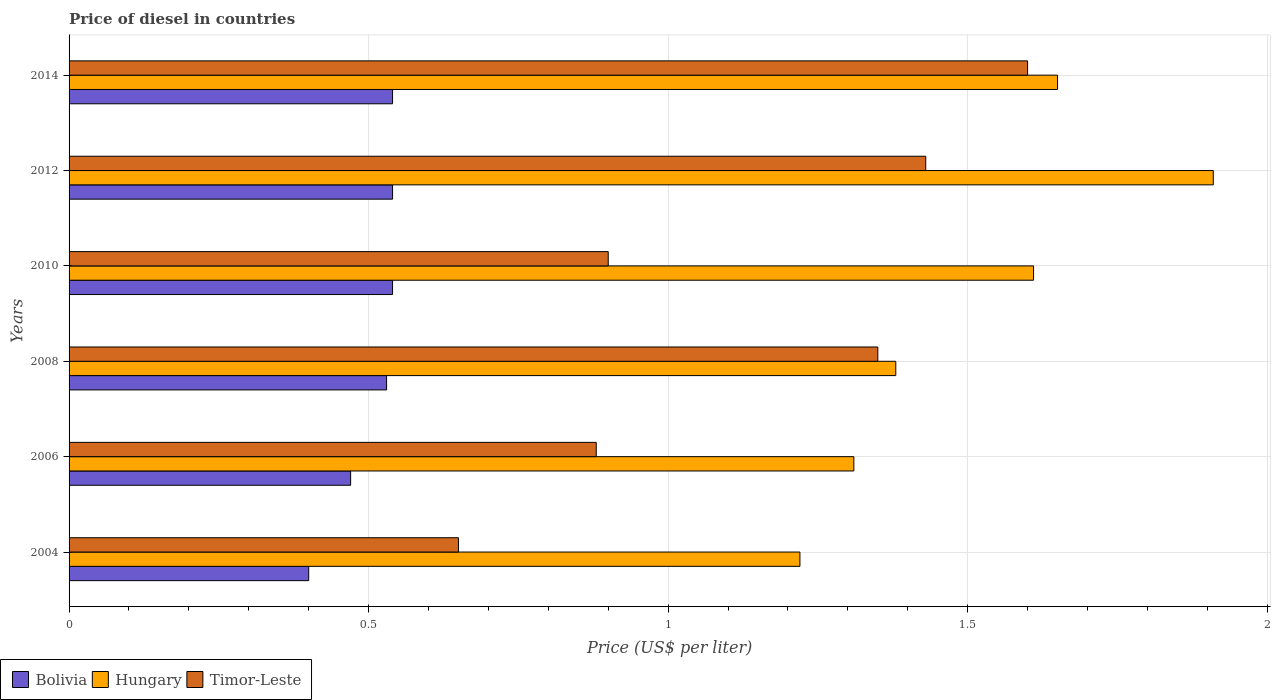How many groups of bars are there?
Offer a very short reply. 6. Are the number of bars per tick equal to the number of legend labels?
Offer a terse response. Yes. How many bars are there on the 4th tick from the bottom?
Offer a very short reply. 3. What is the price of diesel in Timor-Leste in 2006?
Your answer should be compact. 0.88. Across all years, what is the maximum price of diesel in Bolivia?
Your answer should be compact. 0.54. Across all years, what is the minimum price of diesel in Hungary?
Your answer should be compact. 1.22. In which year was the price of diesel in Hungary maximum?
Your response must be concise. 2012. In which year was the price of diesel in Hungary minimum?
Provide a short and direct response. 2004. What is the total price of diesel in Timor-Leste in the graph?
Provide a short and direct response. 6.81. What is the difference between the price of diesel in Bolivia in 2004 and that in 2010?
Provide a succinct answer. -0.14. What is the difference between the price of diesel in Hungary in 2010 and the price of diesel in Timor-Leste in 2014?
Your answer should be compact. 0.01. What is the average price of diesel in Hungary per year?
Make the answer very short. 1.51. In the year 2006, what is the difference between the price of diesel in Hungary and price of diesel in Timor-Leste?
Provide a short and direct response. 0.43. In how many years, is the price of diesel in Hungary greater than 0.8 US$?
Provide a succinct answer. 6. What is the ratio of the price of diesel in Hungary in 2012 to that in 2014?
Your response must be concise. 1.16. Is the difference between the price of diesel in Hungary in 2004 and 2012 greater than the difference between the price of diesel in Timor-Leste in 2004 and 2012?
Provide a short and direct response. Yes. What is the difference between the highest and the second highest price of diesel in Timor-Leste?
Make the answer very short. 0.17. What is the difference between the highest and the lowest price of diesel in Timor-Leste?
Keep it short and to the point. 0.95. In how many years, is the price of diesel in Bolivia greater than the average price of diesel in Bolivia taken over all years?
Keep it short and to the point. 4. Is the sum of the price of diesel in Timor-Leste in 2004 and 2006 greater than the maximum price of diesel in Hungary across all years?
Offer a very short reply. No. Is it the case that in every year, the sum of the price of diesel in Timor-Leste and price of diesel in Bolivia is greater than the price of diesel in Hungary?
Make the answer very short. No. How many bars are there?
Offer a very short reply. 18. How many years are there in the graph?
Keep it short and to the point. 6. What is the difference between two consecutive major ticks on the X-axis?
Your answer should be very brief. 0.5. Does the graph contain grids?
Your answer should be very brief. Yes. Where does the legend appear in the graph?
Provide a succinct answer. Bottom left. How many legend labels are there?
Provide a short and direct response. 3. How are the legend labels stacked?
Your answer should be very brief. Horizontal. What is the title of the graph?
Keep it short and to the point. Price of diesel in countries. Does "Malaysia" appear as one of the legend labels in the graph?
Your answer should be compact. No. What is the label or title of the X-axis?
Ensure brevity in your answer.  Price (US$ per liter). What is the Price (US$ per liter) of Bolivia in 2004?
Make the answer very short. 0.4. What is the Price (US$ per liter) in Hungary in 2004?
Your answer should be very brief. 1.22. What is the Price (US$ per liter) in Timor-Leste in 2004?
Make the answer very short. 0.65. What is the Price (US$ per liter) in Bolivia in 2006?
Ensure brevity in your answer.  0.47. What is the Price (US$ per liter) of Hungary in 2006?
Provide a short and direct response. 1.31. What is the Price (US$ per liter) in Timor-Leste in 2006?
Your answer should be compact. 0.88. What is the Price (US$ per liter) of Bolivia in 2008?
Ensure brevity in your answer.  0.53. What is the Price (US$ per liter) of Hungary in 2008?
Your answer should be very brief. 1.38. What is the Price (US$ per liter) of Timor-Leste in 2008?
Your response must be concise. 1.35. What is the Price (US$ per liter) of Bolivia in 2010?
Your answer should be very brief. 0.54. What is the Price (US$ per liter) in Hungary in 2010?
Offer a very short reply. 1.61. What is the Price (US$ per liter) in Bolivia in 2012?
Provide a succinct answer. 0.54. What is the Price (US$ per liter) in Hungary in 2012?
Your answer should be compact. 1.91. What is the Price (US$ per liter) in Timor-Leste in 2012?
Make the answer very short. 1.43. What is the Price (US$ per liter) in Bolivia in 2014?
Your answer should be compact. 0.54. What is the Price (US$ per liter) of Hungary in 2014?
Your response must be concise. 1.65. Across all years, what is the maximum Price (US$ per liter) in Bolivia?
Make the answer very short. 0.54. Across all years, what is the maximum Price (US$ per liter) of Hungary?
Your answer should be compact. 1.91. Across all years, what is the minimum Price (US$ per liter) in Bolivia?
Your response must be concise. 0.4. Across all years, what is the minimum Price (US$ per liter) in Hungary?
Provide a succinct answer. 1.22. Across all years, what is the minimum Price (US$ per liter) of Timor-Leste?
Make the answer very short. 0.65. What is the total Price (US$ per liter) in Bolivia in the graph?
Offer a very short reply. 3.02. What is the total Price (US$ per liter) in Hungary in the graph?
Your answer should be very brief. 9.08. What is the total Price (US$ per liter) in Timor-Leste in the graph?
Provide a succinct answer. 6.81. What is the difference between the Price (US$ per liter) in Bolivia in 2004 and that in 2006?
Your response must be concise. -0.07. What is the difference between the Price (US$ per liter) of Hungary in 2004 and that in 2006?
Offer a terse response. -0.09. What is the difference between the Price (US$ per liter) of Timor-Leste in 2004 and that in 2006?
Keep it short and to the point. -0.23. What is the difference between the Price (US$ per liter) of Bolivia in 2004 and that in 2008?
Offer a very short reply. -0.13. What is the difference between the Price (US$ per liter) in Hungary in 2004 and that in 2008?
Make the answer very short. -0.16. What is the difference between the Price (US$ per liter) of Timor-Leste in 2004 and that in 2008?
Your answer should be compact. -0.7. What is the difference between the Price (US$ per liter) in Bolivia in 2004 and that in 2010?
Your answer should be compact. -0.14. What is the difference between the Price (US$ per liter) in Hungary in 2004 and that in 2010?
Your answer should be very brief. -0.39. What is the difference between the Price (US$ per liter) in Timor-Leste in 2004 and that in 2010?
Your answer should be compact. -0.25. What is the difference between the Price (US$ per liter) in Bolivia in 2004 and that in 2012?
Offer a very short reply. -0.14. What is the difference between the Price (US$ per liter) of Hungary in 2004 and that in 2012?
Your response must be concise. -0.69. What is the difference between the Price (US$ per liter) of Timor-Leste in 2004 and that in 2012?
Offer a terse response. -0.78. What is the difference between the Price (US$ per liter) of Bolivia in 2004 and that in 2014?
Make the answer very short. -0.14. What is the difference between the Price (US$ per liter) of Hungary in 2004 and that in 2014?
Make the answer very short. -0.43. What is the difference between the Price (US$ per liter) in Timor-Leste in 2004 and that in 2014?
Offer a terse response. -0.95. What is the difference between the Price (US$ per liter) in Bolivia in 2006 and that in 2008?
Your answer should be very brief. -0.06. What is the difference between the Price (US$ per liter) of Hungary in 2006 and that in 2008?
Ensure brevity in your answer.  -0.07. What is the difference between the Price (US$ per liter) in Timor-Leste in 2006 and that in 2008?
Make the answer very short. -0.47. What is the difference between the Price (US$ per liter) in Bolivia in 2006 and that in 2010?
Provide a short and direct response. -0.07. What is the difference between the Price (US$ per liter) in Timor-Leste in 2006 and that in 2010?
Offer a terse response. -0.02. What is the difference between the Price (US$ per liter) in Bolivia in 2006 and that in 2012?
Provide a succinct answer. -0.07. What is the difference between the Price (US$ per liter) in Hungary in 2006 and that in 2012?
Provide a short and direct response. -0.6. What is the difference between the Price (US$ per liter) in Timor-Leste in 2006 and that in 2012?
Keep it short and to the point. -0.55. What is the difference between the Price (US$ per liter) in Bolivia in 2006 and that in 2014?
Provide a short and direct response. -0.07. What is the difference between the Price (US$ per liter) in Hungary in 2006 and that in 2014?
Make the answer very short. -0.34. What is the difference between the Price (US$ per liter) of Timor-Leste in 2006 and that in 2014?
Offer a terse response. -0.72. What is the difference between the Price (US$ per liter) of Bolivia in 2008 and that in 2010?
Provide a short and direct response. -0.01. What is the difference between the Price (US$ per liter) of Hungary in 2008 and that in 2010?
Offer a terse response. -0.23. What is the difference between the Price (US$ per liter) of Timor-Leste in 2008 and that in 2010?
Make the answer very short. 0.45. What is the difference between the Price (US$ per liter) of Bolivia in 2008 and that in 2012?
Your answer should be very brief. -0.01. What is the difference between the Price (US$ per liter) in Hungary in 2008 and that in 2012?
Your answer should be compact. -0.53. What is the difference between the Price (US$ per liter) in Timor-Leste in 2008 and that in 2012?
Your answer should be compact. -0.08. What is the difference between the Price (US$ per liter) of Bolivia in 2008 and that in 2014?
Offer a very short reply. -0.01. What is the difference between the Price (US$ per liter) in Hungary in 2008 and that in 2014?
Ensure brevity in your answer.  -0.27. What is the difference between the Price (US$ per liter) of Timor-Leste in 2008 and that in 2014?
Your answer should be very brief. -0.25. What is the difference between the Price (US$ per liter) in Bolivia in 2010 and that in 2012?
Give a very brief answer. 0. What is the difference between the Price (US$ per liter) of Hungary in 2010 and that in 2012?
Your response must be concise. -0.3. What is the difference between the Price (US$ per liter) of Timor-Leste in 2010 and that in 2012?
Offer a terse response. -0.53. What is the difference between the Price (US$ per liter) of Bolivia in 2010 and that in 2014?
Provide a short and direct response. 0. What is the difference between the Price (US$ per liter) of Hungary in 2010 and that in 2014?
Keep it short and to the point. -0.04. What is the difference between the Price (US$ per liter) of Bolivia in 2012 and that in 2014?
Your answer should be very brief. 0. What is the difference between the Price (US$ per liter) in Hungary in 2012 and that in 2014?
Make the answer very short. 0.26. What is the difference between the Price (US$ per liter) of Timor-Leste in 2012 and that in 2014?
Your answer should be very brief. -0.17. What is the difference between the Price (US$ per liter) of Bolivia in 2004 and the Price (US$ per liter) of Hungary in 2006?
Your answer should be compact. -0.91. What is the difference between the Price (US$ per liter) in Bolivia in 2004 and the Price (US$ per liter) in Timor-Leste in 2006?
Make the answer very short. -0.48. What is the difference between the Price (US$ per liter) of Hungary in 2004 and the Price (US$ per liter) of Timor-Leste in 2006?
Provide a succinct answer. 0.34. What is the difference between the Price (US$ per liter) of Bolivia in 2004 and the Price (US$ per liter) of Hungary in 2008?
Give a very brief answer. -0.98. What is the difference between the Price (US$ per liter) in Bolivia in 2004 and the Price (US$ per liter) in Timor-Leste in 2008?
Keep it short and to the point. -0.95. What is the difference between the Price (US$ per liter) in Hungary in 2004 and the Price (US$ per liter) in Timor-Leste in 2008?
Offer a very short reply. -0.13. What is the difference between the Price (US$ per liter) of Bolivia in 2004 and the Price (US$ per liter) of Hungary in 2010?
Provide a succinct answer. -1.21. What is the difference between the Price (US$ per liter) of Bolivia in 2004 and the Price (US$ per liter) of Timor-Leste in 2010?
Ensure brevity in your answer.  -0.5. What is the difference between the Price (US$ per liter) of Hungary in 2004 and the Price (US$ per liter) of Timor-Leste in 2010?
Provide a short and direct response. 0.32. What is the difference between the Price (US$ per liter) in Bolivia in 2004 and the Price (US$ per liter) in Hungary in 2012?
Your answer should be compact. -1.51. What is the difference between the Price (US$ per liter) of Bolivia in 2004 and the Price (US$ per liter) of Timor-Leste in 2012?
Your answer should be compact. -1.03. What is the difference between the Price (US$ per liter) of Hungary in 2004 and the Price (US$ per liter) of Timor-Leste in 2012?
Your response must be concise. -0.21. What is the difference between the Price (US$ per liter) of Bolivia in 2004 and the Price (US$ per liter) of Hungary in 2014?
Provide a succinct answer. -1.25. What is the difference between the Price (US$ per liter) in Bolivia in 2004 and the Price (US$ per liter) in Timor-Leste in 2014?
Your answer should be very brief. -1.2. What is the difference between the Price (US$ per liter) of Hungary in 2004 and the Price (US$ per liter) of Timor-Leste in 2014?
Keep it short and to the point. -0.38. What is the difference between the Price (US$ per liter) in Bolivia in 2006 and the Price (US$ per liter) in Hungary in 2008?
Your answer should be compact. -0.91. What is the difference between the Price (US$ per liter) of Bolivia in 2006 and the Price (US$ per liter) of Timor-Leste in 2008?
Give a very brief answer. -0.88. What is the difference between the Price (US$ per liter) of Hungary in 2006 and the Price (US$ per liter) of Timor-Leste in 2008?
Provide a short and direct response. -0.04. What is the difference between the Price (US$ per liter) of Bolivia in 2006 and the Price (US$ per liter) of Hungary in 2010?
Give a very brief answer. -1.14. What is the difference between the Price (US$ per liter) in Bolivia in 2006 and the Price (US$ per liter) in Timor-Leste in 2010?
Your response must be concise. -0.43. What is the difference between the Price (US$ per liter) of Hungary in 2006 and the Price (US$ per liter) of Timor-Leste in 2010?
Offer a terse response. 0.41. What is the difference between the Price (US$ per liter) of Bolivia in 2006 and the Price (US$ per liter) of Hungary in 2012?
Your answer should be compact. -1.44. What is the difference between the Price (US$ per liter) in Bolivia in 2006 and the Price (US$ per liter) in Timor-Leste in 2012?
Your response must be concise. -0.96. What is the difference between the Price (US$ per liter) of Hungary in 2006 and the Price (US$ per liter) of Timor-Leste in 2012?
Give a very brief answer. -0.12. What is the difference between the Price (US$ per liter) in Bolivia in 2006 and the Price (US$ per liter) in Hungary in 2014?
Provide a short and direct response. -1.18. What is the difference between the Price (US$ per liter) of Bolivia in 2006 and the Price (US$ per liter) of Timor-Leste in 2014?
Ensure brevity in your answer.  -1.13. What is the difference between the Price (US$ per liter) in Hungary in 2006 and the Price (US$ per liter) in Timor-Leste in 2014?
Offer a terse response. -0.29. What is the difference between the Price (US$ per liter) of Bolivia in 2008 and the Price (US$ per liter) of Hungary in 2010?
Offer a terse response. -1.08. What is the difference between the Price (US$ per liter) in Bolivia in 2008 and the Price (US$ per liter) in Timor-Leste in 2010?
Give a very brief answer. -0.37. What is the difference between the Price (US$ per liter) in Hungary in 2008 and the Price (US$ per liter) in Timor-Leste in 2010?
Offer a terse response. 0.48. What is the difference between the Price (US$ per liter) in Bolivia in 2008 and the Price (US$ per liter) in Hungary in 2012?
Give a very brief answer. -1.38. What is the difference between the Price (US$ per liter) of Bolivia in 2008 and the Price (US$ per liter) of Hungary in 2014?
Keep it short and to the point. -1.12. What is the difference between the Price (US$ per liter) of Bolivia in 2008 and the Price (US$ per liter) of Timor-Leste in 2014?
Give a very brief answer. -1.07. What is the difference between the Price (US$ per liter) of Hungary in 2008 and the Price (US$ per liter) of Timor-Leste in 2014?
Offer a very short reply. -0.22. What is the difference between the Price (US$ per liter) of Bolivia in 2010 and the Price (US$ per liter) of Hungary in 2012?
Keep it short and to the point. -1.37. What is the difference between the Price (US$ per liter) of Bolivia in 2010 and the Price (US$ per liter) of Timor-Leste in 2012?
Make the answer very short. -0.89. What is the difference between the Price (US$ per liter) of Hungary in 2010 and the Price (US$ per liter) of Timor-Leste in 2012?
Give a very brief answer. 0.18. What is the difference between the Price (US$ per liter) in Bolivia in 2010 and the Price (US$ per liter) in Hungary in 2014?
Ensure brevity in your answer.  -1.11. What is the difference between the Price (US$ per liter) of Bolivia in 2010 and the Price (US$ per liter) of Timor-Leste in 2014?
Your response must be concise. -1.06. What is the difference between the Price (US$ per liter) in Hungary in 2010 and the Price (US$ per liter) in Timor-Leste in 2014?
Keep it short and to the point. 0.01. What is the difference between the Price (US$ per liter) of Bolivia in 2012 and the Price (US$ per liter) of Hungary in 2014?
Provide a short and direct response. -1.11. What is the difference between the Price (US$ per liter) of Bolivia in 2012 and the Price (US$ per liter) of Timor-Leste in 2014?
Keep it short and to the point. -1.06. What is the difference between the Price (US$ per liter) of Hungary in 2012 and the Price (US$ per liter) of Timor-Leste in 2014?
Your answer should be compact. 0.31. What is the average Price (US$ per liter) of Bolivia per year?
Provide a short and direct response. 0.5. What is the average Price (US$ per liter) in Hungary per year?
Give a very brief answer. 1.51. What is the average Price (US$ per liter) in Timor-Leste per year?
Your answer should be very brief. 1.14. In the year 2004, what is the difference between the Price (US$ per liter) of Bolivia and Price (US$ per liter) of Hungary?
Provide a short and direct response. -0.82. In the year 2004, what is the difference between the Price (US$ per liter) in Bolivia and Price (US$ per liter) in Timor-Leste?
Offer a very short reply. -0.25. In the year 2004, what is the difference between the Price (US$ per liter) of Hungary and Price (US$ per liter) of Timor-Leste?
Your answer should be compact. 0.57. In the year 2006, what is the difference between the Price (US$ per liter) of Bolivia and Price (US$ per liter) of Hungary?
Give a very brief answer. -0.84. In the year 2006, what is the difference between the Price (US$ per liter) in Bolivia and Price (US$ per liter) in Timor-Leste?
Provide a succinct answer. -0.41. In the year 2006, what is the difference between the Price (US$ per liter) of Hungary and Price (US$ per liter) of Timor-Leste?
Make the answer very short. 0.43. In the year 2008, what is the difference between the Price (US$ per liter) of Bolivia and Price (US$ per liter) of Hungary?
Your answer should be very brief. -0.85. In the year 2008, what is the difference between the Price (US$ per liter) of Bolivia and Price (US$ per liter) of Timor-Leste?
Ensure brevity in your answer.  -0.82. In the year 2010, what is the difference between the Price (US$ per liter) in Bolivia and Price (US$ per liter) in Hungary?
Your response must be concise. -1.07. In the year 2010, what is the difference between the Price (US$ per liter) in Bolivia and Price (US$ per liter) in Timor-Leste?
Ensure brevity in your answer.  -0.36. In the year 2010, what is the difference between the Price (US$ per liter) in Hungary and Price (US$ per liter) in Timor-Leste?
Give a very brief answer. 0.71. In the year 2012, what is the difference between the Price (US$ per liter) of Bolivia and Price (US$ per liter) of Hungary?
Give a very brief answer. -1.37. In the year 2012, what is the difference between the Price (US$ per liter) of Bolivia and Price (US$ per liter) of Timor-Leste?
Offer a terse response. -0.89. In the year 2012, what is the difference between the Price (US$ per liter) of Hungary and Price (US$ per liter) of Timor-Leste?
Keep it short and to the point. 0.48. In the year 2014, what is the difference between the Price (US$ per liter) of Bolivia and Price (US$ per liter) of Hungary?
Offer a terse response. -1.11. In the year 2014, what is the difference between the Price (US$ per liter) of Bolivia and Price (US$ per liter) of Timor-Leste?
Give a very brief answer. -1.06. What is the ratio of the Price (US$ per liter) of Bolivia in 2004 to that in 2006?
Your answer should be compact. 0.85. What is the ratio of the Price (US$ per liter) of Hungary in 2004 to that in 2006?
Give a very brief answer. 0.93. What is the ratio of the Price (US$ per liter) of Timor-Leste in 2004 to that in 2006?
Offer a very short reply. 0.74. What is the ratio of the Price (US$ per liter) of Bolivia in 2004 to that in 2008?
Keep it short and to the point. 0.75. What is the ratio of the Price (US$ per liter) of Hungary in 2004 to that in 2008?
Make the answer very short. 0.88. What is the ratio of the Price (US$ per liter) of Timor-Leste in 2004 to that in 2008?
Offer a very short reply. 0.48. What is the ratio of the Price (US$ per liter) of Bolivia in 2004 to that in 2010?
Give a very brief answer. 0.74. What is the ratio of the Price (US$ per liter) of Hungary in 2004 to that in 2010?
Offer a very short reply. 0.76. What is the ratio of the Price (US$ per liter) of Timor-Leste in 2004 to that in 2010?
Provide a short and direct response. 0.72. What is the ratio of the Price (US$ per liter) in Bolivia in 2004 to that in 2012?
Offer a terse response. 0.74. What is the ratio of the Price (US$ per liter) of Hungary in 2004 to that in 2012?
Make the answer very short. 0.64. What is the ratio of the Price (US$ per liter) of Timor-Leste in 2004 to that in 2012?
Your response must be concise. 0.45. What is the ratio of the Price (US$ per liter) in Bolivia in 2004 to that in 2014?
Provide a succinct answer. 0.74. What is the ratio of the Price (US$ per liter) in Hungary in 2004 to that in 2014?
Offer a very short reply. 0.74. What is the ratio of the Price (US$ per liter) in Timor-Leste in 2004 to that in 2014?
Your answer should be very brief. 0.41. What is the ratio of the Price (US$ per liter) in Bolivia in 2006 to that in 2008?
Provide a succinct answer. 0.89. What is the ratio of the Price (US$ per liter) in Hungary in 2006 to that in 2008?
Make the answer very short. 0.95. What is the ratio of the Price (US$ per liter) in Timor-Leste in 2006 to that in 2008?
Offer a very short reply. 0.65. What is the ratio of the Price (US$ per liter) in Bolivia in 2006 to that in 2010?
Your response must be concise. 0.87. What is the ratio of the Price (US$ per liter) of Hungary in 2006 to that in 2010?
Your answer should be compact. 0.81. What is the ratio of the Price (US$ per liter) in Timor-Leste in 2006 to that in 2010?
Your response must be concise. 0.98. What is the ratio of the Price (US$ per liter) in Bolivia in 2006 to that in 2012?
Your answer should be compact. 0.87. What is the ratio of the Price (US$ per liter) of Hungary in 2006 to that in 2012?
Provide a short and direct response. 0.69. What is the ratio of the Price (US$ per liter) of Timor-Leste in 2006 to that in 2012?
Provide a short and direct response. 0.62. What is the ratio of the Price (US$ per liter) in Bolivia in 2006 to that in 2014?
Your answer should be compact. 0.87. What is the ratio of the Price (US$ per liter) in Hungary in 2006 to that in 2014?
Keep it short and to the point. 0.79. What is the ratio of the Price (US$ per liter) in Timor-Leste in 2006 to that in 2014?
Ensure brevity in your answer.  0.55. What is the ratio of the Price (US$ per liter) of Bolivia in 2008 to that in 2010?
Your answer should be very brief. 0.98. What is the ratio of the Price (US$ per liter) of Bolivia in 2008 to that in 2012?
Your response must be concise. 0.98. What is the ratio of the Price (US$ per liter) of Hungary in 2008 to that in 2012?
Your answer should be compact. 0.72. What is the ratio of the Price (US$ per liter) of Timor-Leste in 2008 to that in 2012?
Offer a very short reply. 0.94. What is the ratio of the Price (US$ per liter) in Bolivia in 2008 to that in 2014?
Your answer should be compact. 0.98. What is the ratio of the Price (US$ per liter) of Hungary in 2008 to that in 2014?
Your response must be concise. 0.84. What is the ratio of the Price (US$ per liter) in Timor-Leste in 2008 to that in 2014?
Make the answer very short. 0.84. What is the ratio of the Price (US$ per liter) in Bolivia in 2010 to that in 2012?
Ensure brevity in your answer.  1. What is the ratio of the Price (US$ per liter) in Hungary in 2010 to that in 2012?
Give a very brief answer. 0.84. What is the ratio of the Price (US$ per liter) in Timor-Leste in 2010 to that in 2012?
Your response must be concise. 0.63. What is the ratio of the Price (US$ per liter) of Bolivia in 2010 to that in 2014?
Provide a succinct answer. 1. What is the ratio of the Price (US$ per liter) in Hungary in 2010 to that in 2014?
Your answer should be compact. 0.98. What is the ratio of the Price (US$ per liter) of Timor-Leste in 2010 to that in 2014?
Your answer should be very brief. 0.56. What is the ratio of the Price (US$ per liter) of Hungary in 2012 to that in 2014?
Provide a succinct answer. 1.16. What is the ratio of the Price (US$ per liter) of Timor-Leste in 2012 to that in 2014?
Your answer should be very brief. 0.89. What is the difference between the highest and the second highest Price (US$ per liter) in Bolivia?
Offer a very short reply. 0. What is the difference between the highest and the second highest Price (US$ per liter) in Hungary?
Make the answer very short. 0.26. What is the difference between the highest and the second highest Price (US$ per liter) in Timor-Leste?
Make the answer very short. 0.17. What is the difference between the highest and the lowest Price (US$ per liter) in Bolivia?
Provide a short and direct response. 0.14. What is the difference between the highest and the lowest Price (US$ per liter) of Hungary?
Offer a terse response. 0.69. What is the difference between the highest and the lowest Price (US$ per liter) of Timor-Leste?
Offer a very short reply. 0.95. 